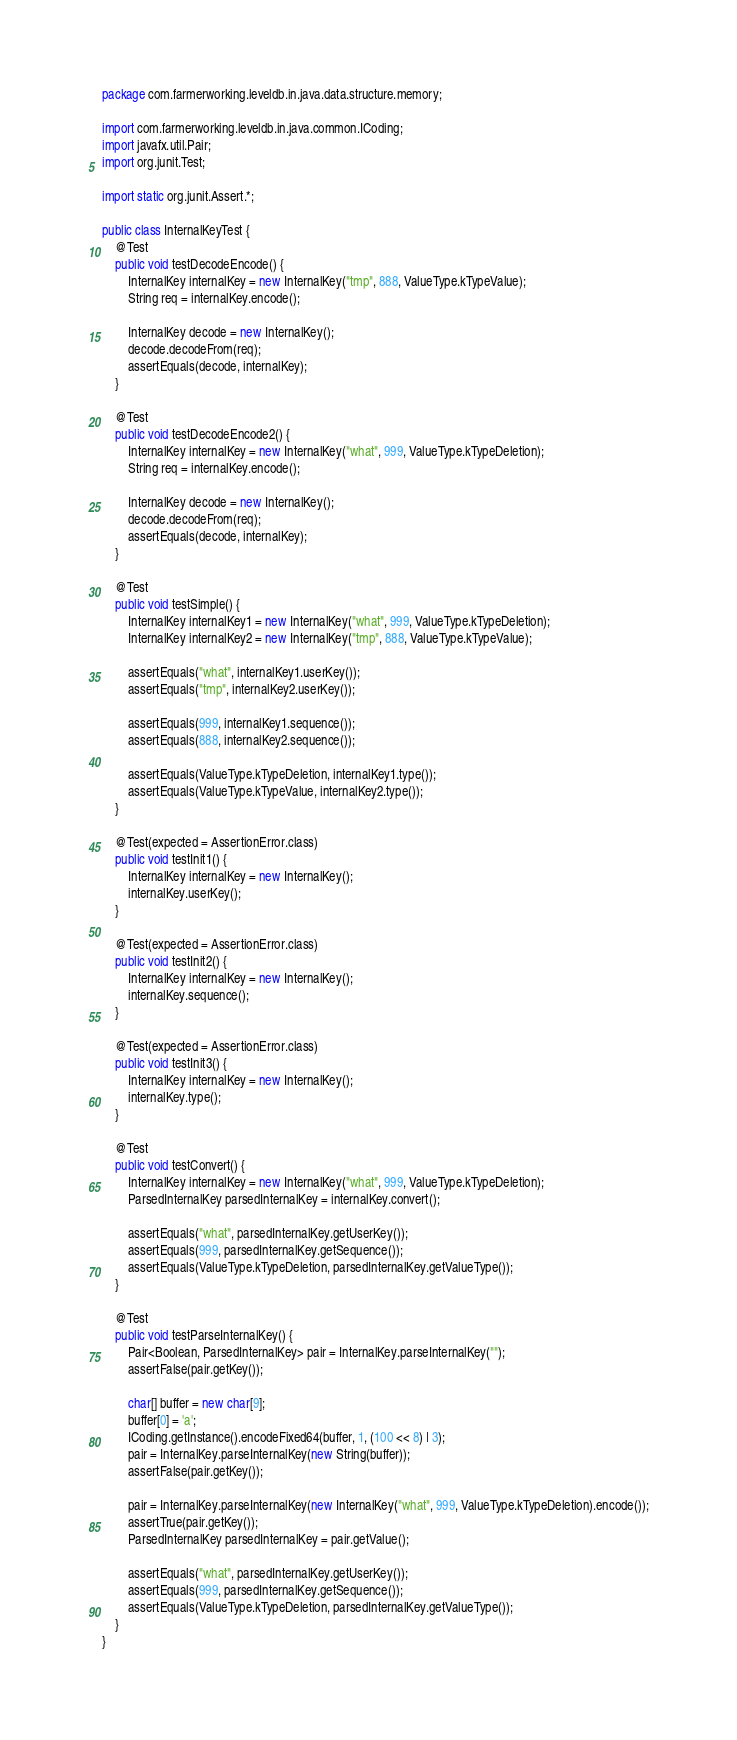<code> <loc_0><loc_0><loc_500><loc_500><_Java_>package com.farmerworking.leveldb.in.java.data.structure.memory;

import com.farmerworking.leveldb.in.java.common.ICoding;
import javafx.util.Pair;
import org.junit.Test;

import static org.junit.Assert.*;

public class InternalKeyTest {
    @Test
    public void testDecodeEncode() {
        InternalKey internalKey = new InternalKey("tmp", 888, ValueType.kTypeValue);
        String req = internalKey.encode();

        InternalKey decode = new InternalKey();
        decode.decodeFrom(req);
        assertEquals(decode, internalKey);
    }

    @Test
    public void testDecodeEncode2() {
        InternalKey internalKey = new InternalKey("what", 999, ValueType.kTypeDeletion);
        String req = internalKey.encode();

        InternalKey decode = new InternalKey();
        decode.decodeFrom(req);
        assertEquals(decode, internalKey);
    }

    @Test
    public void testSimple() {
        InternalKey internalKey1 = new InternalKey("what", 999, ValueType.kTypeDeletion);
        InternalKey internalKey2 = new InternalKey("tmp", 888, ValueType.kTypeValue);

        assertEquals("what", internalKey1.userKey());
        assertEquals("tmp", internalKey2.userKey());

        assertEquals(999, internalKey1.sequence());
        assertEquals(888, internalKey2.sequence());

        assertEquals(ValueType.kTypeDeletion, internalKey1.type());
        assertEquals(ValueType.kTypeValue, internalKey2.type());
    }

    @Test(expected = AssertionError.class)
    public void testInit1() {
        InternalKey internalKey = new InternalKey();
        internalKey.userKey();
    }

    @Test(expected = AssertionError.class)
    public void testInit2() {
        InternalKey internalKey = new InternalKey();
        internalKey.sequence();
    }

    @Test(expected = AssertionError.class)
    public void testInit3() {
        InternalKey internalKey = new InternalKey();
        internalKey.type();
    }

    @Test
    public void testConvert() {
        InternalKey internalKey = new InternalKey("what", 999, ValueType.kTypeDeletion);
        ParsedInternalKey parsedInternalKey = internalKey.convert();

        assertEquals("what", parsedInternalKey.getUserKey());
        assertEquals(999, parsedInternalKey.getSequence());
        assertEquals(ValueType.kTypeDeletion, parsedInternalKey.getValueType());
    }

    @Test
    public void testParseInternalKey() {
        Pair<Boolean, ParsedInternalKey> pair = InternalKey.parseInternalKey("");
        assertFalse(pair.getKey());

        char[] buffer = new char[9];
        buffer[0] = 'a';
        ICoding.getInstance().encodeFixed64(buffer, 1, (100 << 8) | 3);
        pair = InternalKey.parseInternalKey(new String(buffer));
        assertFalse(pair.getKey());

        pair = InternalKey.parseInternalKey(new InternalKey("what", 999, ValueType.kTypeDeletion).encode());
        assertTrue(pair.getKey());
        ParsedInternalKey parsedInternalKey = pair.getValue();

        assertEquals("what", parsedInternalKey.getUserKey());
        assertEquals(999, parsedInternalKey.getSequence());
        assertEquals(ValueType.kTypeDeletion, parsedInternalKey.getValueType());
    }
}</code> 